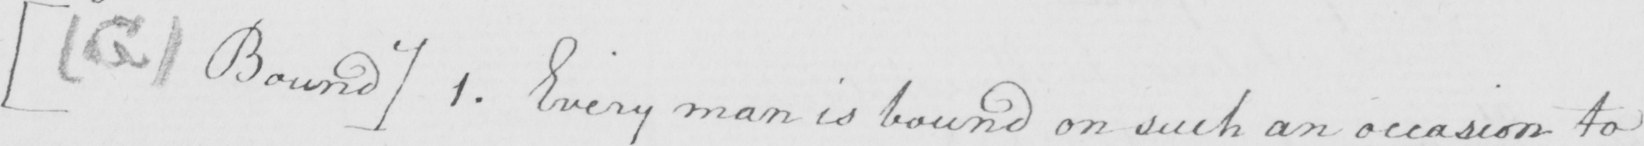Transcribe the text shown in this historical manuscript line. [  ( G )  Bound ]  1 . Every man is bound in such an occasion to 